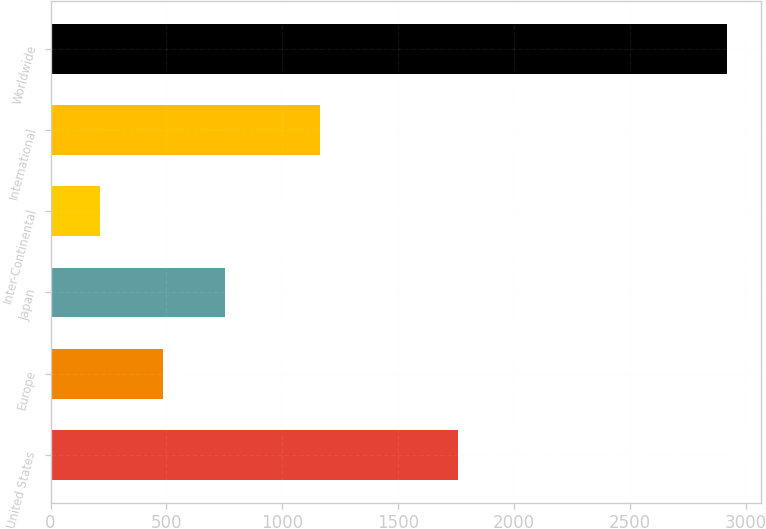<chart> <loc_0><loc_0><loc_500><loc_500><bar_chart><fcel>United States<fcel>Europe<fcel>Japan<fcel>Inter-Continental<fcel>International<fcel>Worldwide<nl><fcel>1756<fcel>483.6<fcel>754.2<fcel>213<fcel>1163<fcel>2919<nl></chart> 